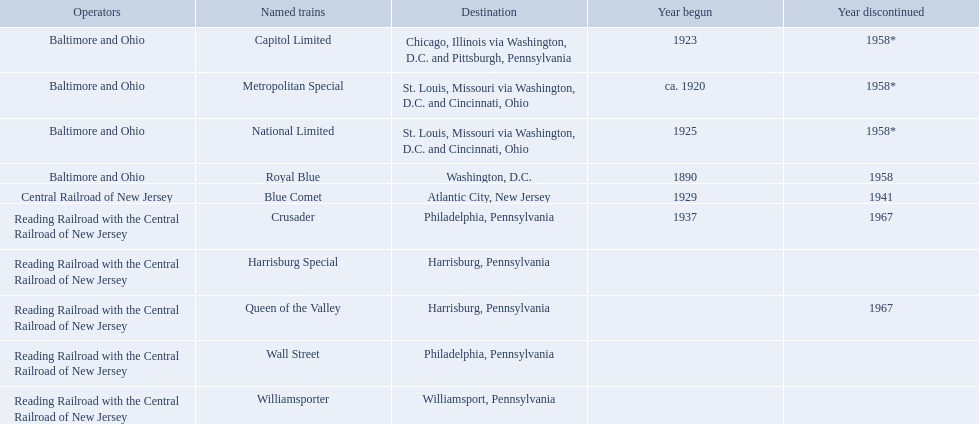What are the destinations of the central railroad of new jersey terminal? Chicago, Illinois via Washington, D.C. and Pittsburgh, Pennsylvania, St. Louis, Missouri via Washington, D.C. and Cincinnati, Ohio, St. Louis, Missouri via Washington, D.C. and Cincinnati, Ohio, Washington, D.C., Atlantic City, New Jersey, Philadelphia, Pennsylvania, Harrisburg, Pennsylvania, Harrisburg, Pennsylvania, Philadelphia, Pennsylvania, Williamsport, Pennsylvania. Which of these destinations is at the top of the list? Chicago, Illinois via Washington, D.C. and Pittsburgh, Pennsylvania. Which of the trains are operated by reading railroad with the central railroad of new jersey? Crusader, Harrisburg Special, Queen of the Valley, Wall Street, Williamsporter. Of these trains, which of them had a destination of philadelphia, pennsylvania? Crusader, Wall Street. Out of these two trains, which one is discontinued? Crusader. What are the destinations of the central railroad of new jersey terminal? Chicago, Illinois via Washington, D.C. and Pittsburgh, Pennsylvania, St. Louis, Missouri via Washington, D.C. and Cincinnati, Ohio, St. Louis, Missouri via Washington, D.C. and Cincinnati, Ohio, Washington, D.C., Atlantic City, New Jersey, Philadelphia, Pennsylvania, Harrisburg, Pennsylvania, Harrisburg, Pennsylvania, Philadelphia, Pennsylvania, Williamsport, Pennsylvania. Which of these destinations is at the top of the list? Chicago, Illinois via Washington, D.C. and Pittsburgh, Pennsylvania. What destinations are there? Chicago, Illinois via Washington, D.C. and Pittsburgh, Pennsylvania, St. Louis, Missouri via Washington, D.C. and Cincinnati, Ohio, St. Louis, Missouri via Washington, D.C. and Cincinnati, Ohio, Washington, D.C., Atlantic City, New Jersey, Philadelphia, Pennsylvania, Harrisburg, Pennsylvania, Harrisburg, Pennsylvania, Philadelphia, Pennsylvania, Williamsport, Pennsylvania. Which one is at the top of the list? Chicago, Illinois via Washington, D.C. and Pittsburgh, Pennsylvania. Which trains are managed by reading railroad along with the central railroad of new jersey? Crusader, Harrisburg Special, Queen of the Valley, Wall Street, Williamsporter. Of these trains, which were heading to philadelphia, pennsylvania? Crusader, Wall Street. From these two trains, which one has been discontinued? Crusader. What were all the stops? Chicago, Illinois via Washington, D.C. and Pittsburgh, Pennsylvania, St. Louis, Missouri via Washington, D.C. and Cincinnati, Ohio, St. Louis, Missouri via Washington, D.C. and Cincinnati, Ohio, Washington, D.C., Atlantic City, New Jersey, Philadelphia, Pennsylvania, Harrisburg, Pennsylvania, Harrisburg, Pennsylvania, Philadelphia, Pennsylvania, Williamsport, Pennsylvania. And what were the names of the trains? Capitol Limited, Metropolitan Special, National Limited, Royal Blue, Blue Comet, Crusader, Harrisburg Special, Queen of the Valley, Wall Street, Williamsporter. Of those, and in addition to wall street, which train operated to philadelphia, pennsylvania? Crusader. What places can we visit? Chicago, Illinois via Washington, D.C. and Pittsburgh, Pennsylvania, St. Louis, Missouri via Washington, D.C. and Cincinnati, Ohio, St. Louis, Missouri via Washington, D.C. and Cincinnati, Ohio, Washington, D.C., Atlantic City, New Jersey, Philadelphia, Pennsylvania, Harrisburg, Pennsylvania, Harrisburg, Pennsylvania, Philadelphia, Pennsylvania, Williamsport, Pennsylvania. Which one is the most prioritized? Chicago, Illinois via Washington, D.C. and Pittsburgh, Pennsylvania. 